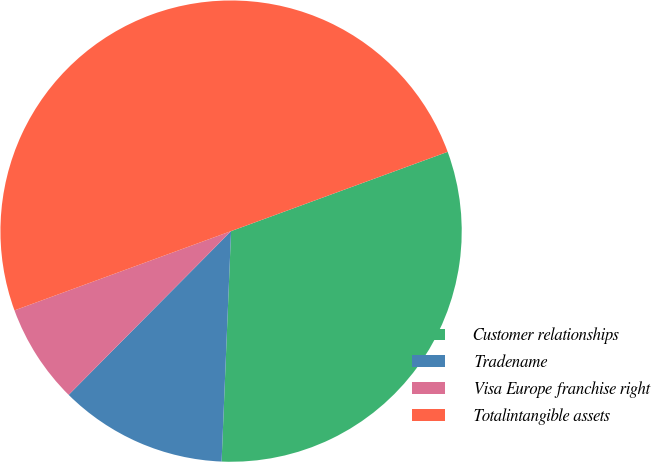Convert chart to OTSL. <chart><loc_0><loc_0><loc_500><loc_500><pie_chart><fcel>Customer relationships<fcel>Tradename<fcel>Visa Europe franchise right<fcel>Totalintangible assets<nl><fcel>31.24%<fcel>11.78%<fcel>6.98%<fcel>50.0%<nl></chart> 